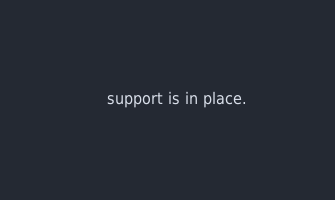Convert code to text. <code><loc_0><loc_0><loc_500><loc_500><_YAML_>    support is in place.
</code> 